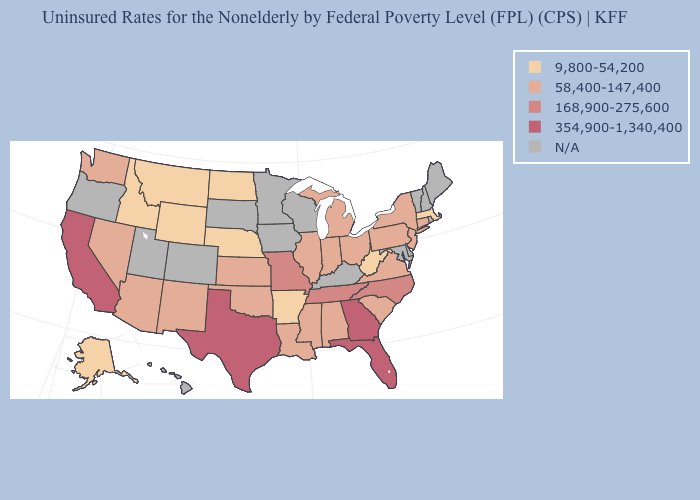Does the map have missing data?
Keep it brief. Yes. Which states have the lowest value in the USA?
Quick response, please. Alaska, Arkansas, Idaho, Massachusetts, Montana, Nebraska, North Dakota, West Virginia, Wyoming. Does West Virginia have the lowest value in the USA?
Give a very brief answer. Yes. Which states have the lowest value in the USA?
Short answer required. Alaska, Arkansas, Idaho, Massachusetts, Montana, Nebraska, North Dakota, West Virginia, Wyoming. What is the lowest value in the USA?
Keep it brief. 9,800-54,200. Which states have the lowest value in the USA?
Write a very short answer. Alaska, Arkansas, Idaho, Massachusetts, Montana, Nebraska, North Dakota, West Virginia, Wyoming. Does Idaho have the lowest value in the USA?
Write a very short answer. Yes. Name the states that have a value in the range 58,400-147,400?
Concise answer only. Alabama, Arizona, Connecticut, Illinois, Indiana, Kansas, Louisiana, Michigan, Mississippi, Nevada, New Jersey, New Mexico, New York, Ohio, Oklahoma, Pennsylvania, South Carolina, Virginia, Washington. Name the states that have a value in the range 354,900-1,340,400?
Quick response, please. California, Florida, Georgia, Texas. What is the value of Kentucky?
Give a very brief answer. N/A. Which states have the lowest value in the South?
Keep it brief. Arkansas, West Virginia. Name the states that have a value in the range 9,800-54,200?
Keep it brief. Alaska, Arkansas, Idaho, Massachusetts, Montana, Nebraska, North Dakota, West Virginia, Wyoming. What is the value of Oklahoma?
Give a very brief answer. 58,400-147,400. Among the states that border Wisconsin , which have the lowest value?
Short answer required. Illinois, Michigan. 